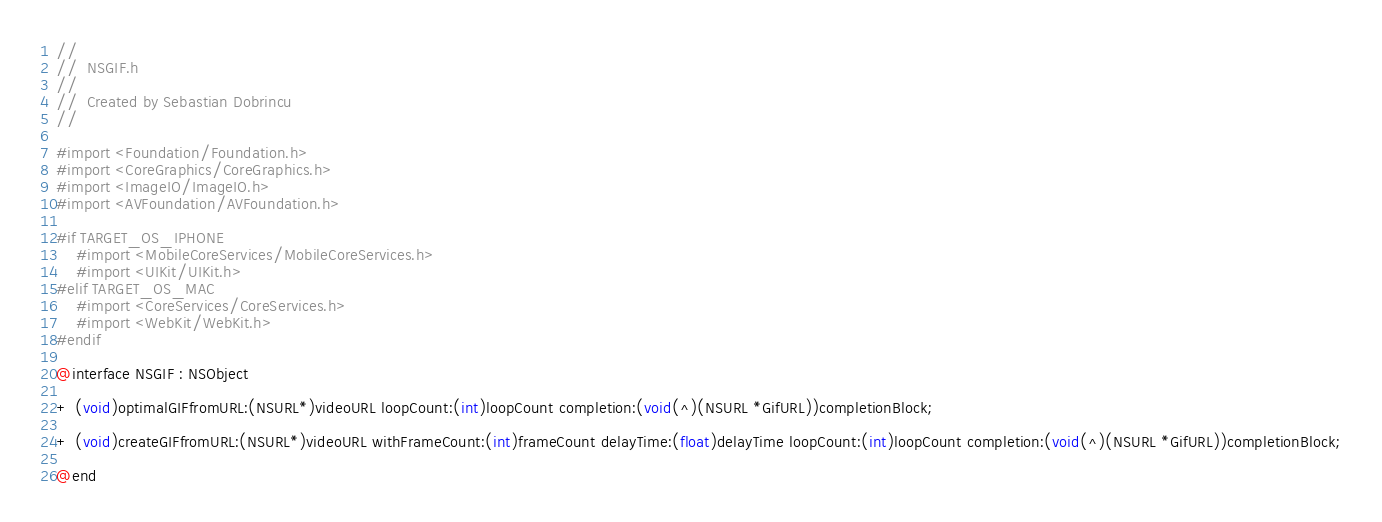<code> <loc_0><loc_0><loc_500><loc_500><_C_>//
//  NSGIF.h
//
//  Created by Sebastian Dobrincu
//

#import <Foundation/Foundation.h>
#import <CoreGraphics/CoreGraphics.h>
#import <ImageIO/ImageIO.h>
#import <AVFoundation/AVFoundation.h>

#if TARGET_OS_IPHONE
    #import <MobileCoreServices/MobileCoreServices.h>
    #import <UIKit/UIKit.h>
#elif TARGET_OS_MAC
    #import <CoreServices/CoreServices.h>
    #import <WebKit/WebKit.h>
#endif

@interface NSGIF : NSObject

+ (void)optimalGIFfromURL:(NSURL*)videoURL loopCount:(int)loopCount completion:(void(^)(NSURL *GifURL))completionBlock;

+ (void)createGIFfromURL:(NSURL*)videoURL withFrameCount:(int)frameCount delayTime:(float)delayTime loopCount:(int)loopCount completion:(void(^)(NSURL *GifURL))completionBlock;

@end
</code> 